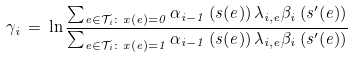Convert formula to latex. <formula><loc_0><loc_0><loc_500><loc_500>\, \gamma _ { i } \, = \, { \ln } \, \frac { \sum _ { e \in \mathcal { T } _ { i } \colon x ( e ) = 0 } \alpha _ { i - 1 } \left ( s ( e ) \right ) \lambda _ { i , e } \beta _ { i } \left ( s ^ { \prime } ( e ) \right ) } { \sum _ { e \in \mathcal { T } _ { i } \colon x ( e ) = 1 } \alpha _ { i - 1 } \left ( s ( e ) \right ) \lambda _ { i , e } \beta _ { i } \left ( s ^ { \prime } ( e ) \right ) }</formula> 